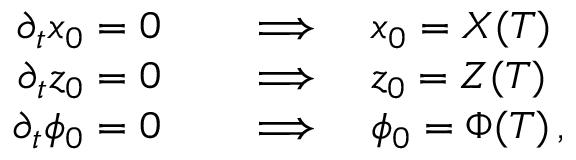Convert formula to latex. <formula><loc_0><loc_0><loc_500><loc_500>\begin{array} { r l } { \partial _ { t } x _ { 0 } = 0 } & \quad \Longrightarrow \quad x _ { 0 } = X ( T ) } \\ { \partial _ { t } z _ { 0 } = 0 } & \quad \Longrightarrow \quad z _ { 0 } = Z ( T ) } \\ { \partial _ { t } \phi _ { 0 } = 0 } & \quad \Longrightarrow \quad \phi _ { 0 } = \Phi ( T ) \, , } \end{array}</formula> 